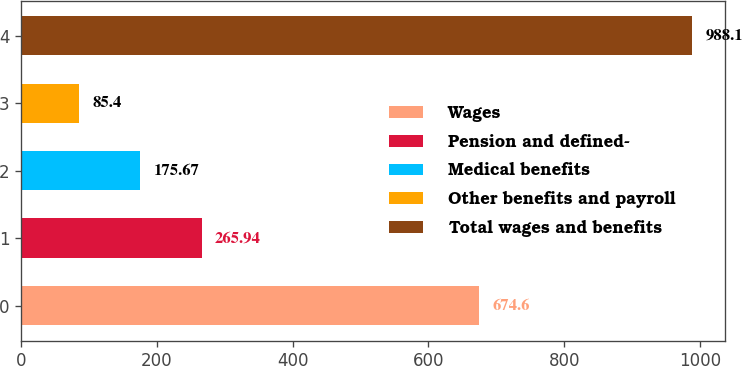Convert chart. <chart><loc_0><loc_0><loc_500><loc_500><bar_chart><fcel>Wages<fcel>Pension and defined-<fcel>Medical benefits<fcel>Other benefits and payroll<fcel>Total wages and benefits<nl><fcel>674.6<fcel>265.94<fcel>175.67<fcel>85.4<fcel>988.1<nl></chart> 